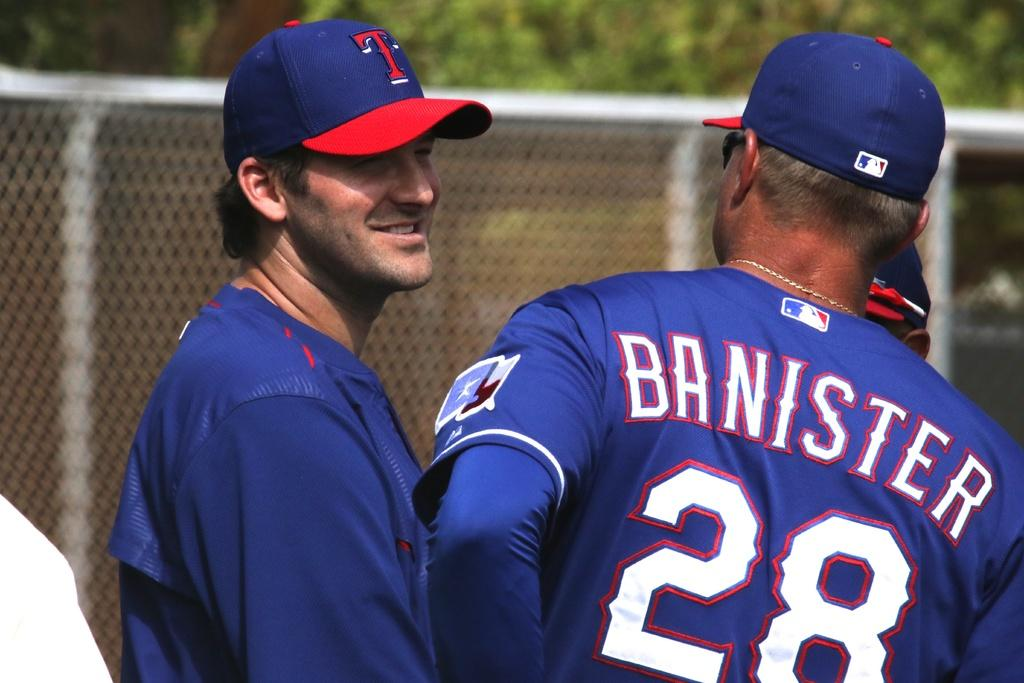<image>
Provide a brief description of the given image. a man with a blue shirt with the name Banister on it 